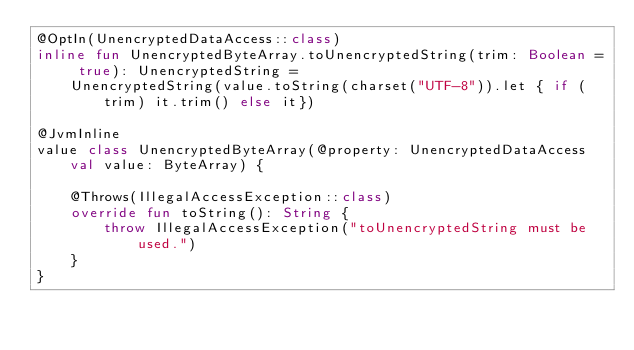<code> <loc_0><loc_0><loc_500><loc_500><_Kotlin_>@OptIn(UnencryptedDataAccess::class)
inline fun UnencryptedByteArray.toUnencryptedString(trim: Boolean = true): UnencryptedString =
    UnencryptedString(value.toString(charset("UTF-8")).let { if (trim) it.trim() else it})

@JvmInline
value class UnencryptedByteArray(@property: UnencryptedDataAccess val value: ByteArray) {

    @Throws(IllegalAccessException::class)
    override fun toString(): String {
        throw IllegalAccessException("toUnencryptedString must be used.")
    }
}
</code> 